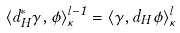<formula> <loc_0><loc_0><loc_500><loc_500>\langle d _ { H } ^ { * } \gamma , \phi \rangle ^ { l - 1 } _ { \kappa } = \langle \gamma , d _ { H } \phi \rangle ^ { l } _ { \kappa }</formula> 